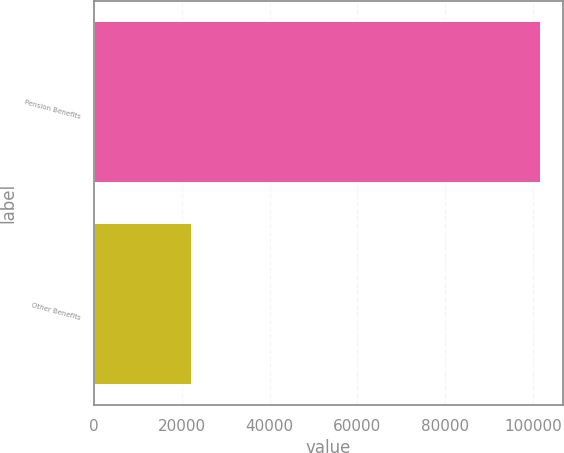Convert chart. <chart><loc_0><loc_0><loc_500><loc_500><bar_chart><fcel>Pension Benefits<fcel>Other Benefits<nl><fcel>101765<fcel>22411<nl></chart> 